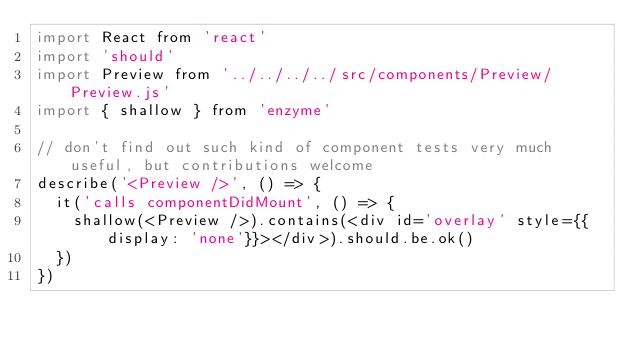Convert code to text. <code><loc_0><loc_0><loc_500><loc_500><_JavaScript_>import React from 'react'
import 'should'
import Preview from '../../../../src/components/Preview/Preview.js'
import { shallow } from 'enzyme'

// don't find out such kind of component tests very much useful, but contributions welcome
describe('<Preview />', () => {
  it('calls componentDidMount', () => {
    shallow(<Preview />).contains(<div id='overlay' style={{display: 'none'}}></div>).should.be.ok()
  })
})
</code> 